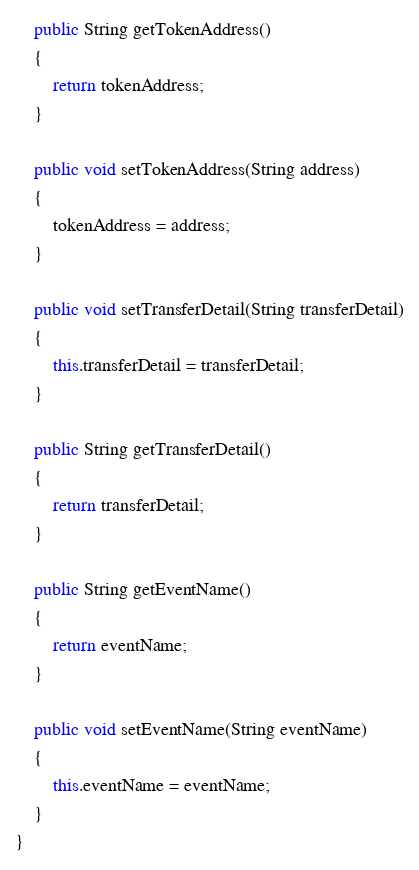Convert code to text. <code><loc_0><loc_0><loc_500><loc_500><_Java_>    public String getTokenAddress()
    {
        return tokenAddress;
    }

    public void setTokenAddress(String address)
    {
        tokenAddress = address;
    }

    public void setTransferDetail(String transferDetail)
    {
        this.transferDetail = transferDetail;
    }

    public String getTransferDetail()
    {
        return transferDetail;
    }

    public String getEventName()
    {
        return eventName;
    }

    public void setEventName(String eventName)
    {
        this.eventName = eventName;
    }
}
</code> 